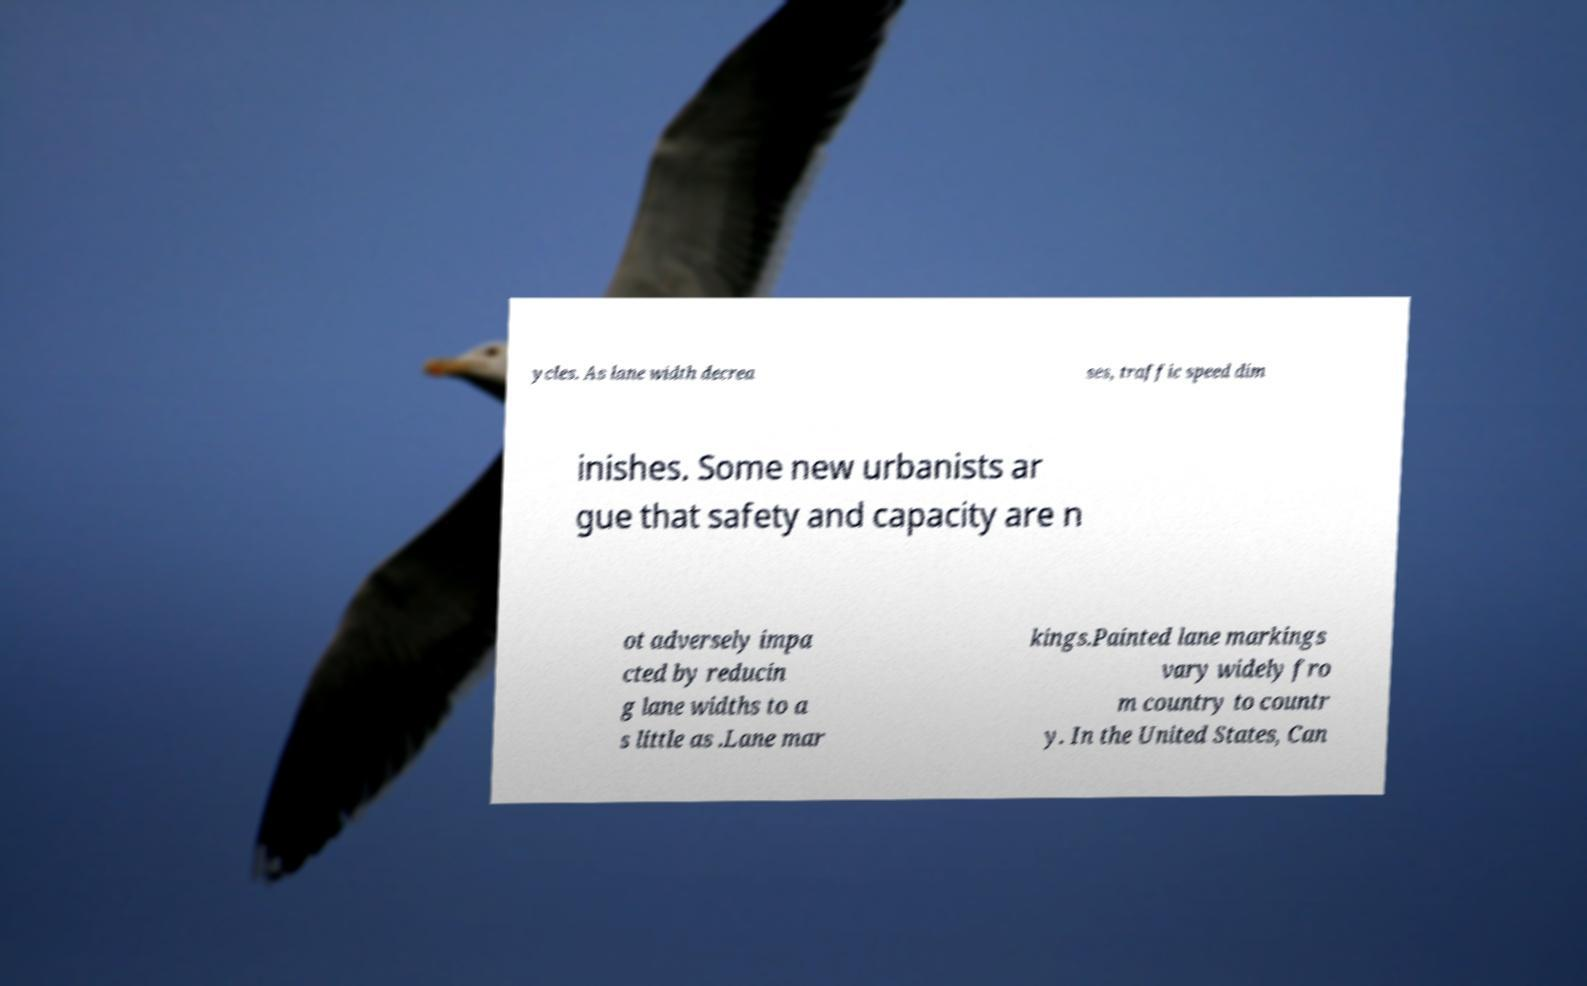Could you assist in decoding the text presented in this image and type it out clearly? ycles. As lane width decrea ses, traffic speed dim inishes. Some new urbanists ar gue that safety and capacity are n ot adversely impa cted by reducin g lane widths to a s little as .Lane mar kings.Painted lane markings vary widely fro m country to countr y. In the United States, Can 